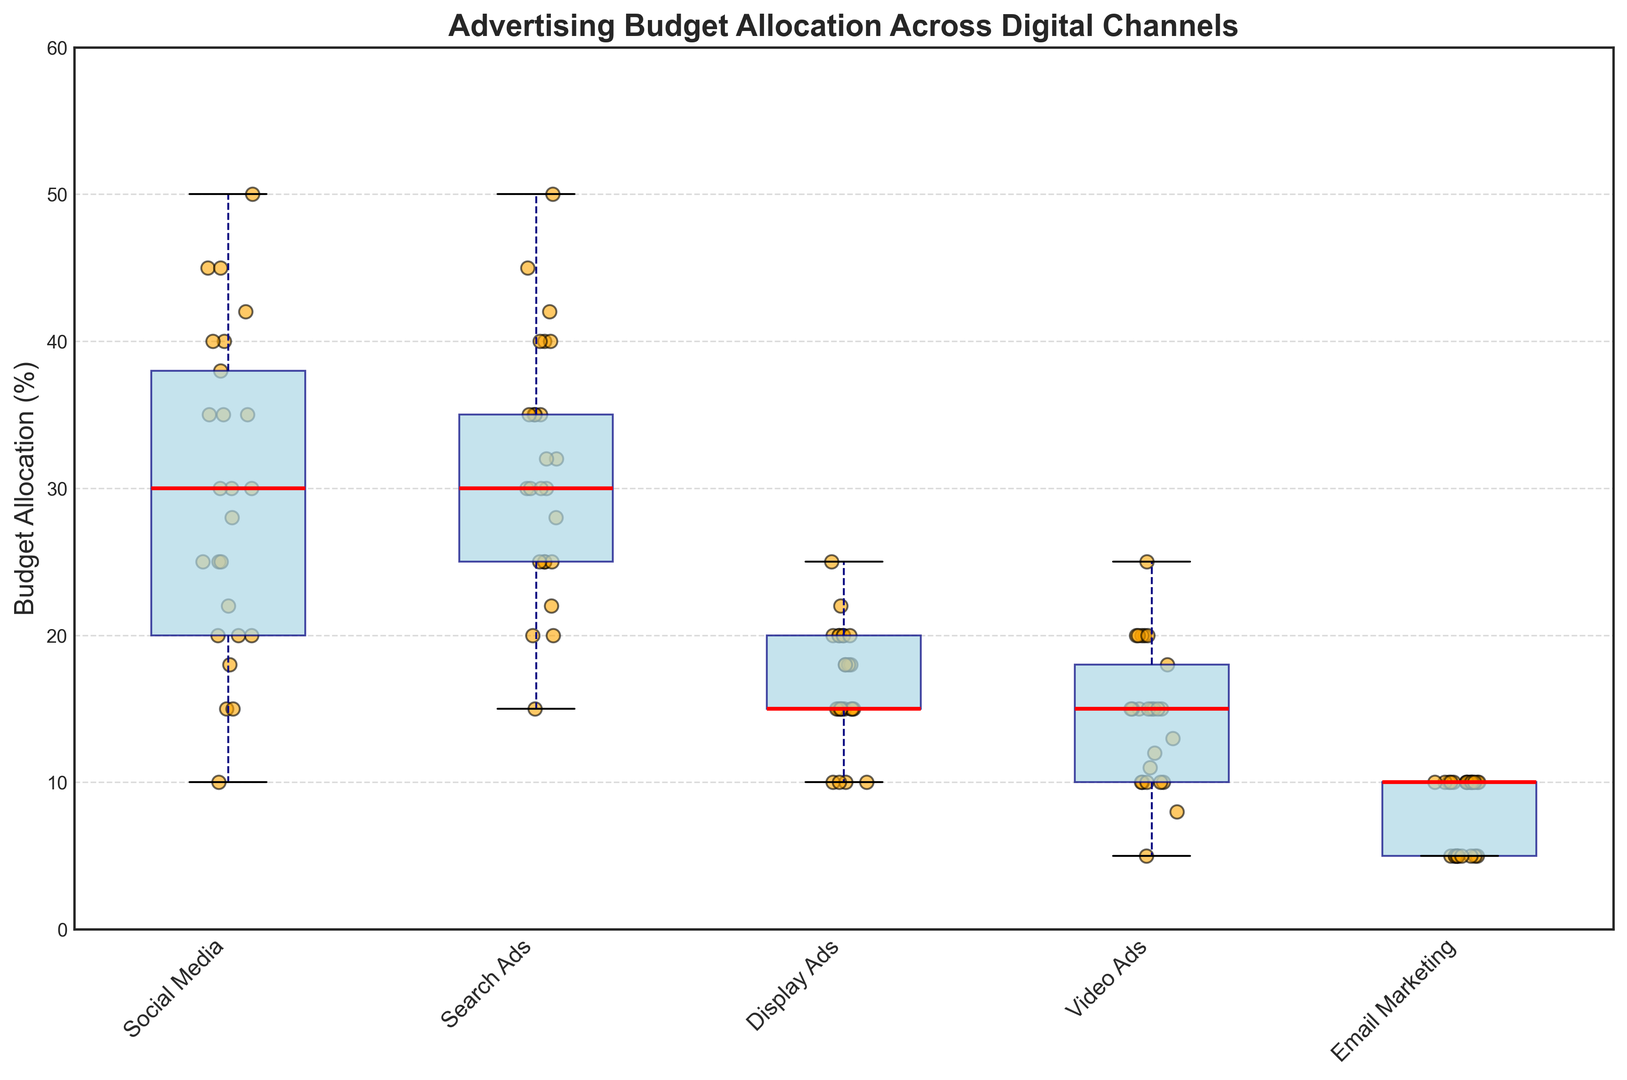What's the median allocation for Social Media? The median is represented by the red line within the box of the Social Media category. By looking at the box plot for Social Media, the median line is located at approximately 30%.
Answer: 30% Which channel has the highest maximum budget allocation? The maximum budget allocation for each channel is shown at the upper whisker tip. By comparing the highest points of the whiskers for all channels, Search Ads has the highest maximum at around 50%.
Answer: Search Ads What is the interquartile range (IQR) for Video Ads? The IQR is the difference between the third quartile (Q3) and the first quartile (Q1). On the box plot, Q3 and Q1 are represented by the top and bottom of the box, respectively. For Video Ads, Q3 is around 20% and Q1 is around 10%, making the IQR 20% - 10% = 10%.
Answer: 10% Which digital channel shows the smallest spread of budget allocations? The spread of data can be interpreted by the length of the whiskers and the size of the box. The smaller the size, the smaller the spread. Email Marketing has the smallest spread, as represented by the shortest whiskers and smallest box.
Answer: Email Marketing Between Retail and Travel sectors, which one allocates more budget to Social Media on average? The average can be visually estimated by comparing how the data points and the box positions are skewed in each sector. Since all sectors are aggregated in the box plot, we'll refer to the general spread of the data. By averaging the noticeable mean (mid-point) values, Travel, with higher upper medians and floats, allocates more to Social Media on average.
Answer: Travel Are there any outliers in Display Ads? Outliers typically appear as isolated points beyond the whiskers. By examining the Display Ads box plot, there are no points that appear beyond the whiskers, hence, no outliers.
Answer: No Which channel has the lowest median budget allocation? The median is indicated by the red line inside each box. Email Marketing has the lowest median, clearly marked by the red line at about 10%.
Answer: Email Marketing How does the variance in budget allocation compare between Social Media and Display Ads? Variance can be visually interpreted through the box plot spread. Social Media has a larger box and longer whiskers compared to Display Ads, indicating a higher variance.
Answer: Social Media has higher variance What is the approximate range of budget allocations for Search Ads in the Technology sector? Range is the difference between the maximum and minimum values. For Search Ads, identify the whisker top and bottom closest to the range for Technology. Approximately, the Technology sector ranges from 20% to 35%, hence a range of 35% - 20% = 15%.
Answer: 15% In which channel does the median sit closer to the first quartile (Q1) than the third quartile (Q3)? The median being closer to Q1 means a longer box segment from the median to Q3. Observing all channels, Video Ads has a median sitting closer to Q1.
Answer: Video Ads 